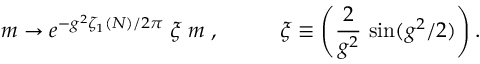<formula> <loc_0><loc_0><loc_500><loc_500>m \rightarrow e ^ { - g ^ { 2 } \zeta _ { 1 } ( N ) / 2 \pi } \, \xi \, m \, , \, \xi \equiv \left ( \frac { 2 } g ^ { 2 } } \, \sin ( g ^ { 2 } / 2 ) \right ) .</formula> 